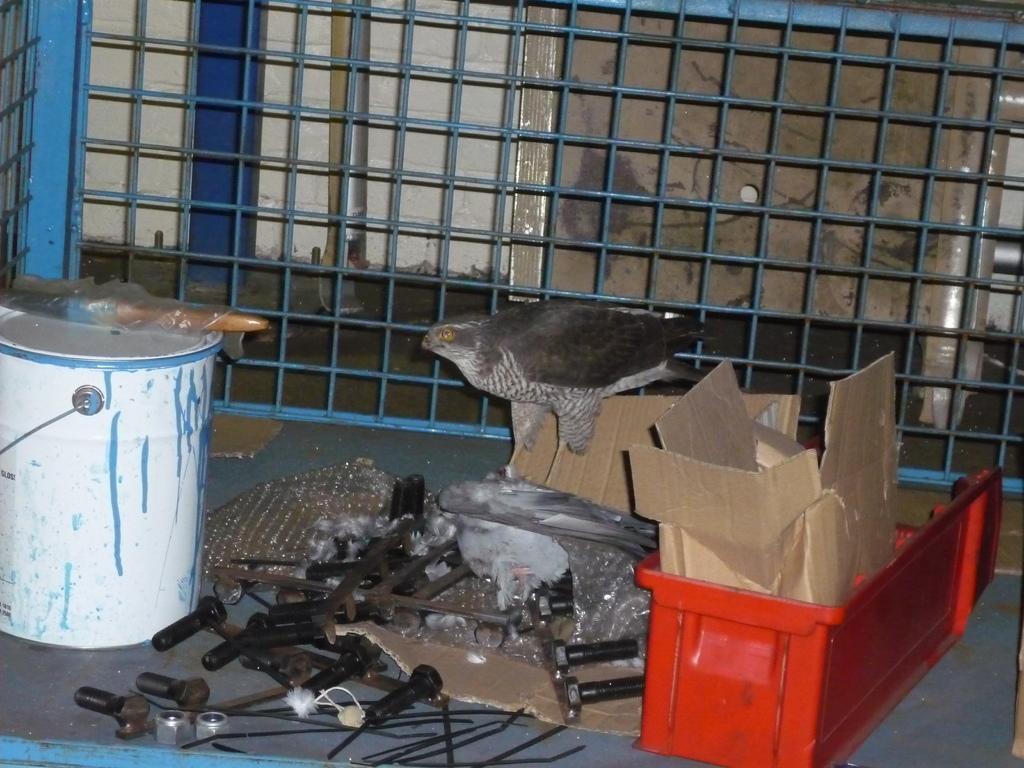How would you summarize this image in a sentence or two? In this picture we can see few tools on the ground, here we can see cardboard boxes, paintbox and a bird and in the background we can see a grille. 